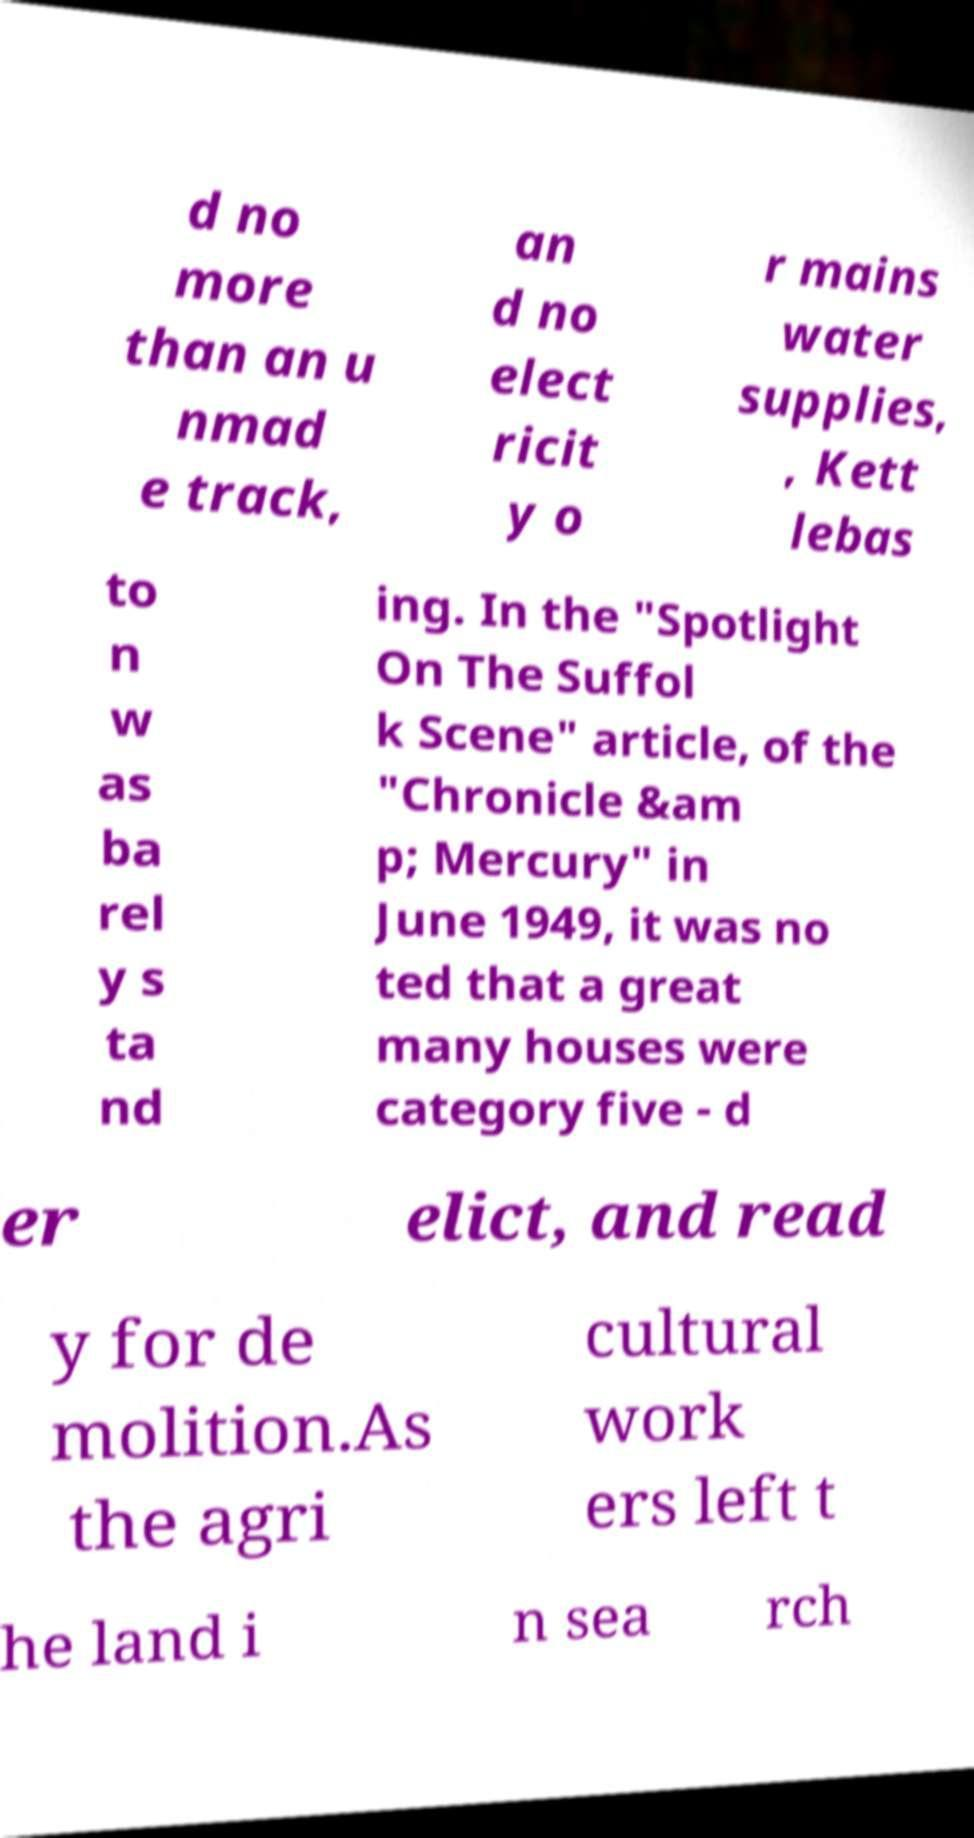Can you read and provide the text displayed in the image?This photo seems to have some interesting text. Can you extract and type it out for me? d no more than an u nmad e track, an d no elect ricit y o r mains water supplies, , Kett lebas to n w as ba rel y s ta nd ing. In the "Spotlight On The Suffol k Scene" article, of the "Chronicle &am p; Mercury" in June 1949, it was no ted that a great many houses were category five - d er elict, and read y for de molition.As the agri cultural work ers left t he land i n sea rch 